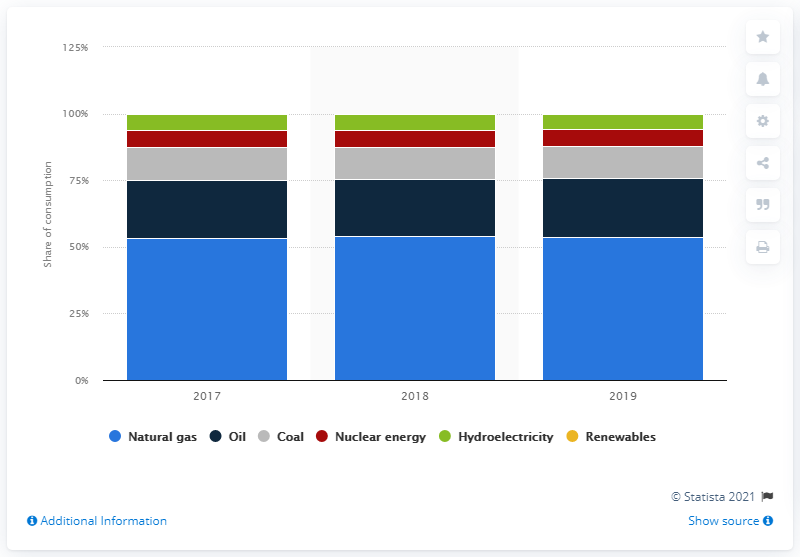Identify some key points in this picture. In 2019, natural gas accounted for 54.23% of Russia's total energy consumption. 